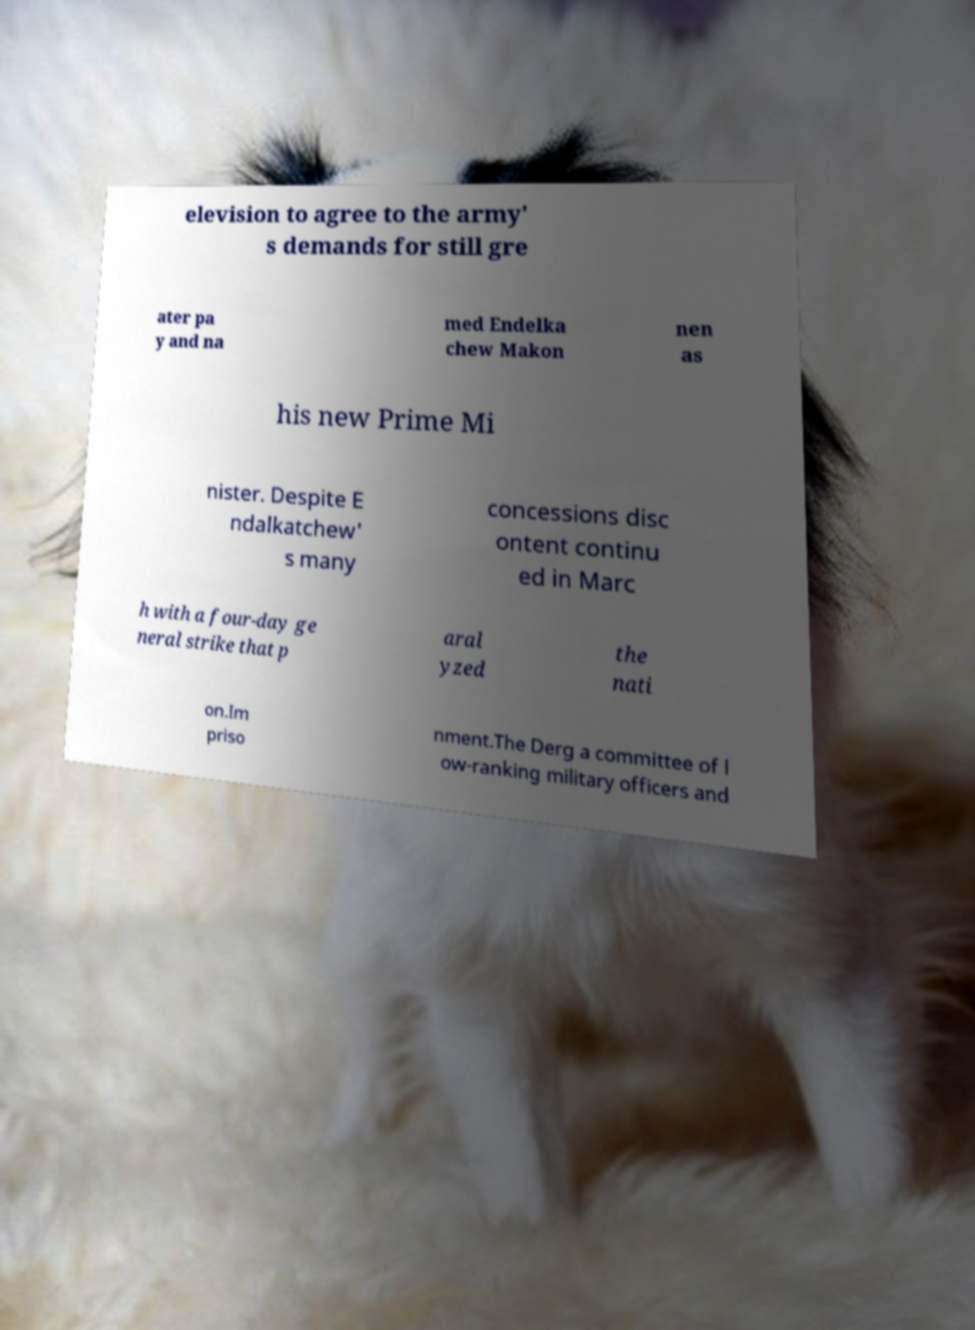Can you read and provide the text displayed in the image?This photo seems to have some interesting text. Can you extract and type it out for me? elevision to agree to the army' s demands for still gre ater pa y and na med Endelka chew Makon nen as his new Prime Mi nister. Despite E ndalkatchew' s many concessions disc ontent continu ed in Marc h with a four-day ge neral strike that p aral yzed the nati on.Im priso nment.The Derg a committee of l ow-ranking military officers and 